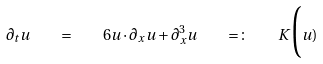<formula> <loc_0><loc_0><loc_500><loc_500>\partial _ { t } u \quad = \quad 6 u \cdot \partial _ { x } u + \partial ^ { 3 } _ { x } u \quad = \colon \quad K \Big ( u )</formula> 